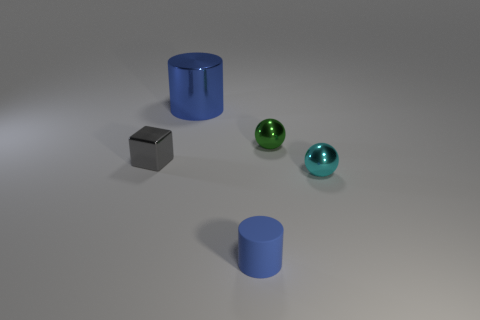Add 3 tiny blue blocks. How many objects exist? 8 Subtract all small gray metallic objects. Subtract all big blue objects. How many objects are left? 3 Add 2 shiny things. How many shiny things are left? 6 Add 3 large yellow metal objects. How many large yellow metal objects exist? 3 Subtract 0 brown spheres. How many objects are left? 5 Subtract all cubes. How many objects are left? 4 